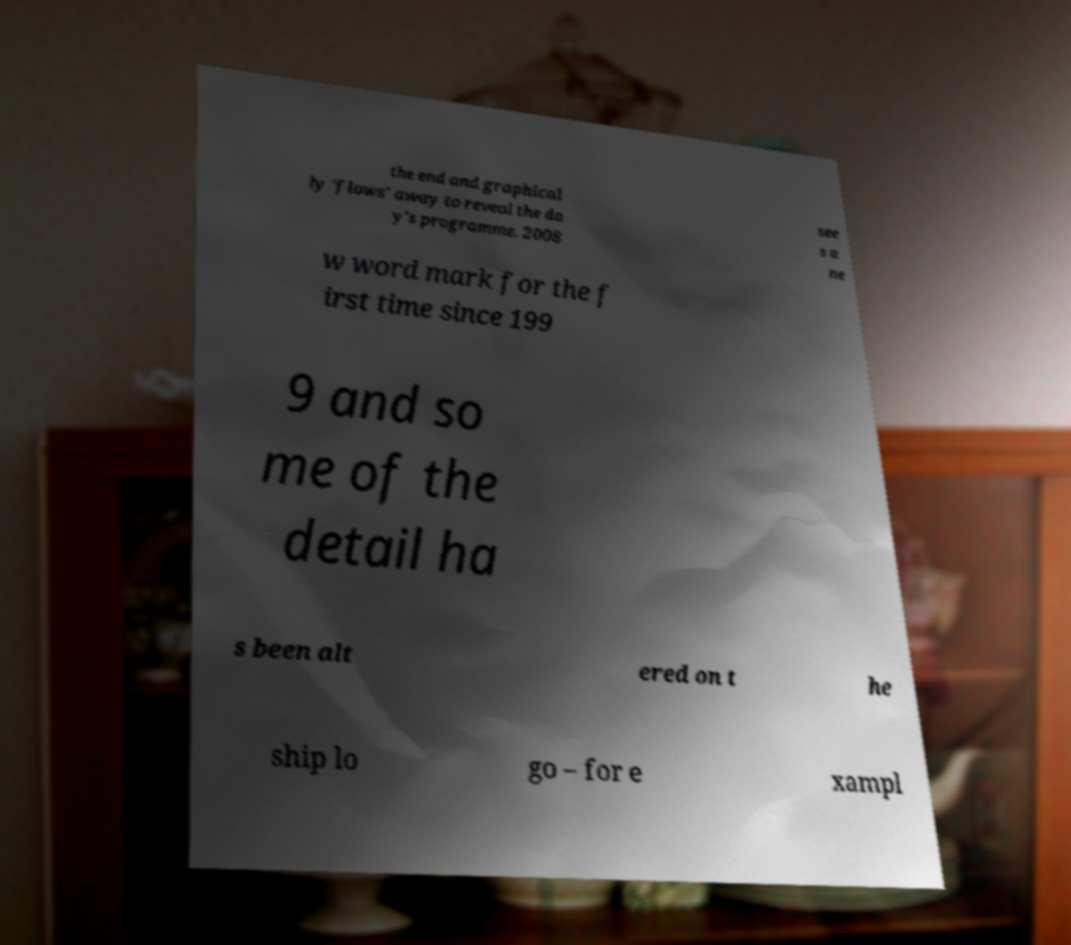Please identify and transcribe the text found in this image. the end and graphical ly 'flows' away to reveal the da y's programme. 2008 see s a ne w word mark for the f irst time since 199 9 and so me of the detail ha s been alt ered on t he ship lo go – for e xampl 